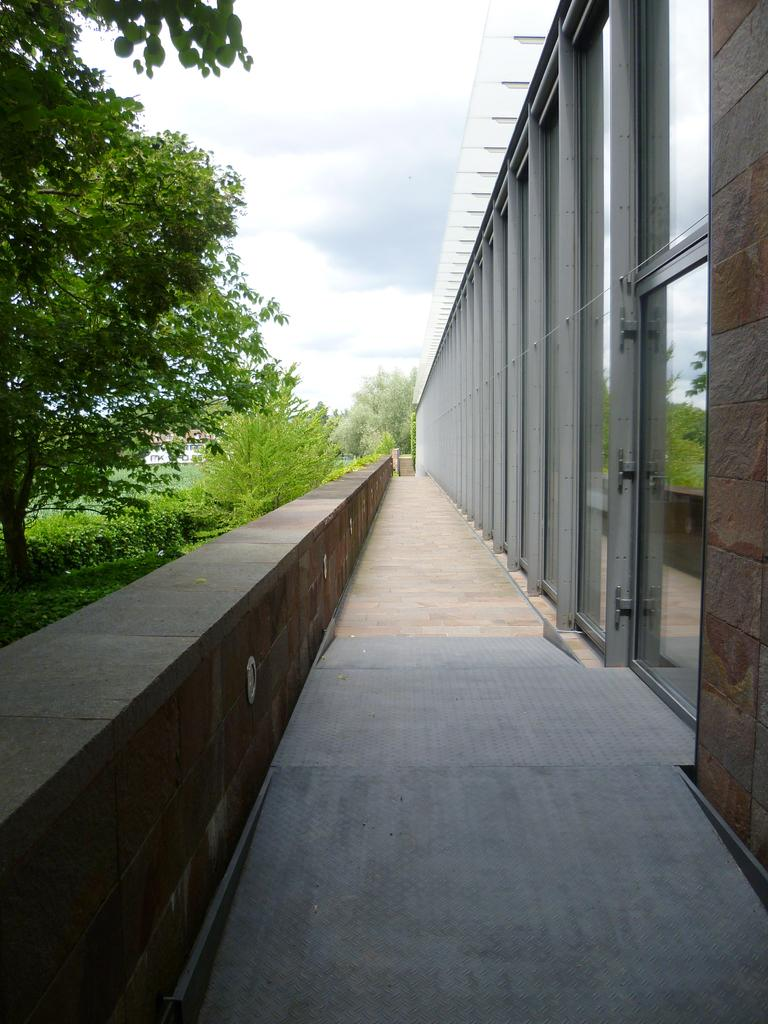What can be seen on the right side of the image? There is a boundary on the right side of the image. What type of vegetation is on the left side of the image? There are trees on the left side of the image. What type of bread can be seen in the image? There is no bread present in the image. What material is the quilt made of in the image? There is no quilt present in the image. 